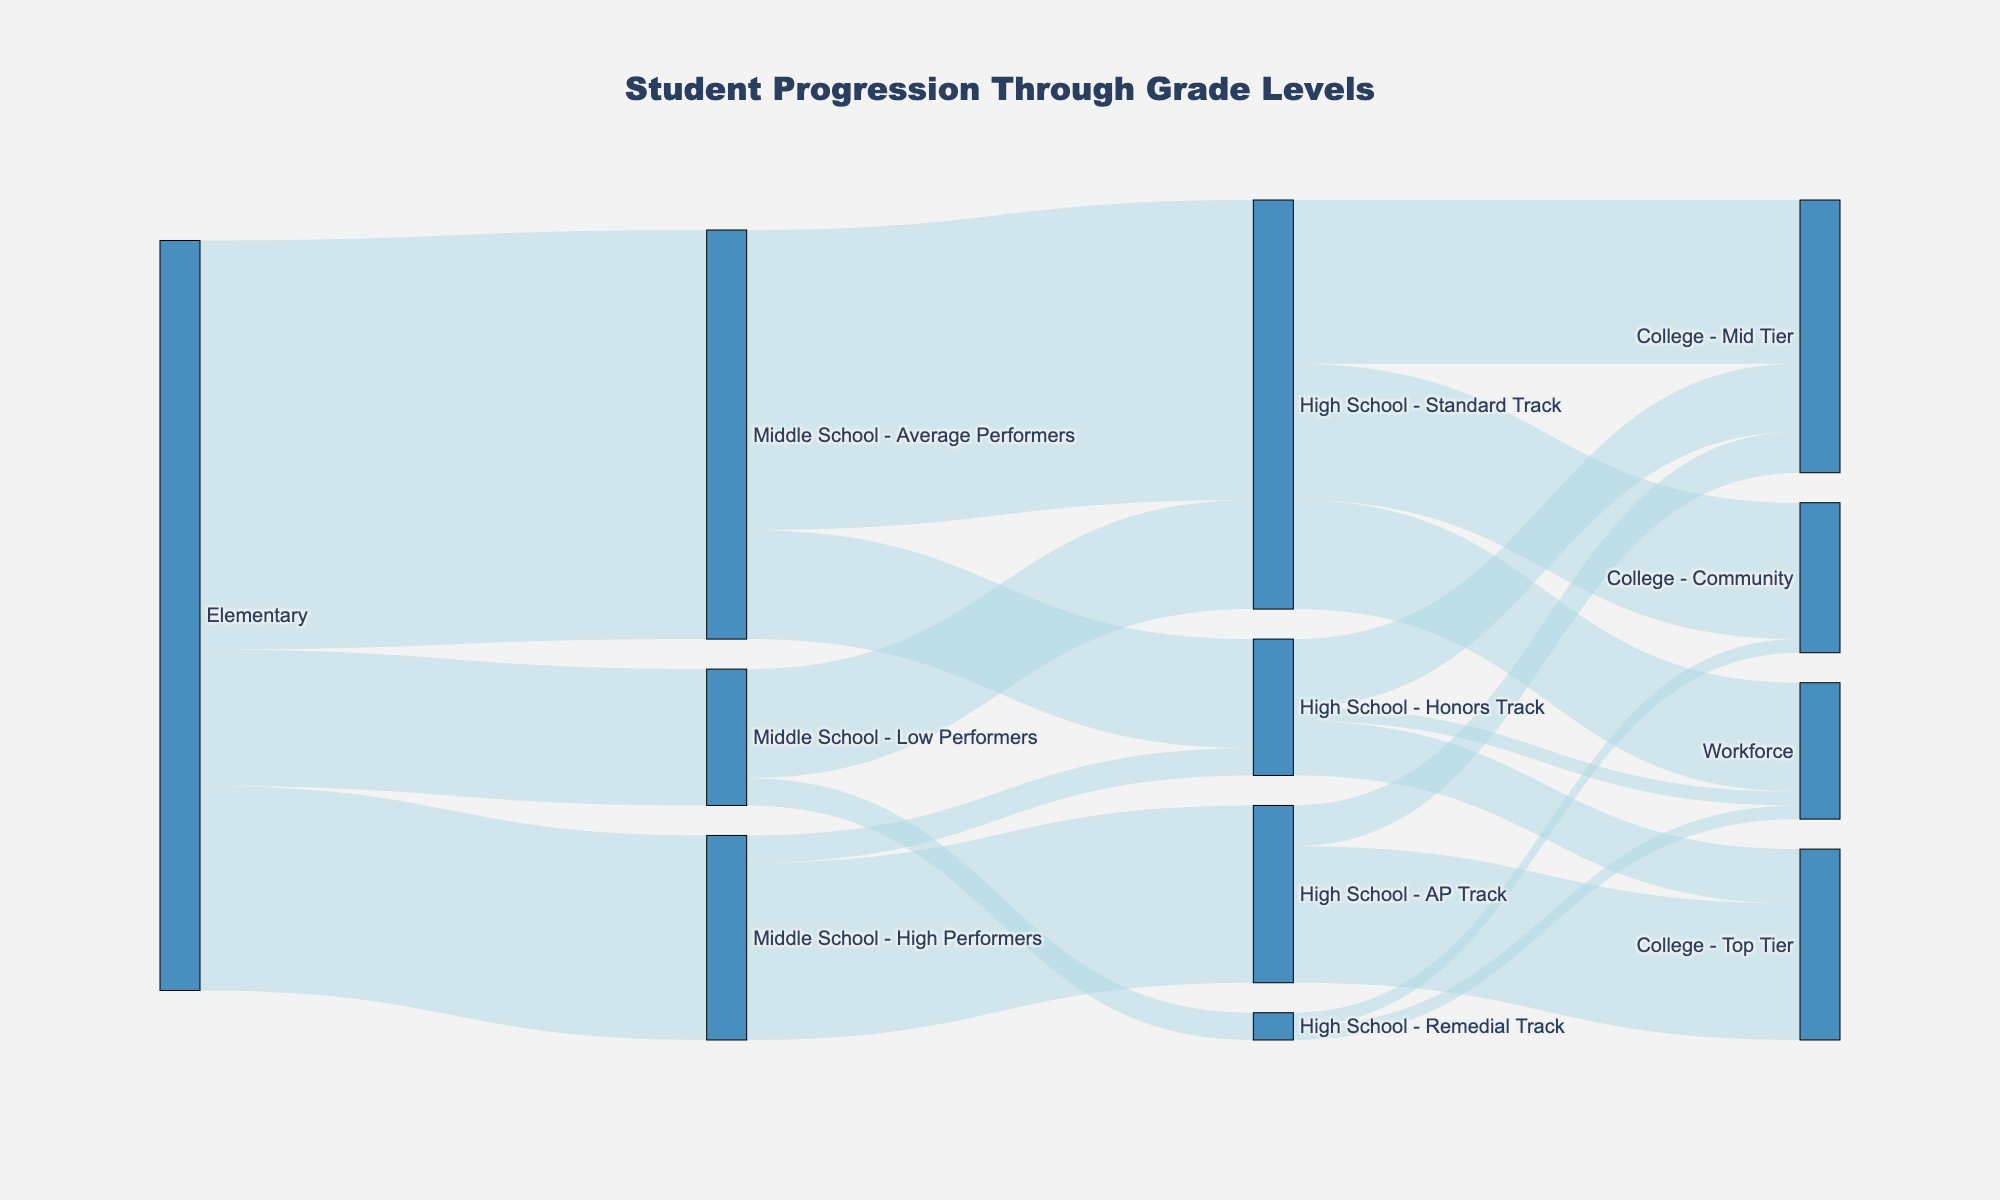What is the title of the figure? The title is usually located at the top of the diagram. In this case, it reads "Student Progression Through Grade Levels".
Answer: Student Progression Through Grade Levels How many students progressed from Middle School - High Performers to High School - AP Track? Find the link from Middle School - High Performers to High School - AP Track in the diagram, the value displayed is 130.
Answer: 130 Which group has the highest number of students entering High School - Standard Track? Examine the links flowing into High School - Standard Track. The flows are from Middle School - Average Performers (220) and Middle School - Low Performers (80). 220 is the higher value.
Answer: Middle School - Average Performers How many students transitioned from Elementary to Middle School? Sum the values for students transitioning from Elementary to all Middle School groups: Middle School - High Performers (150), Middle School - Average Performers (300), Middle School - Low Performers (100). So, 150 + 300 + 100 = 550.
Answer: 550 What is the total number of students who entered the workforce after High School? Sum the values for students entering the workforce from all High School tracks: High School - Honors Track (10), High School - Standard Track (80), High School - Remedial Track (10). So, 10 + 80 + 10 = 100.
Answer: 100 Which transition has the least number of students? Identify the link with the smallest value; here, it is the transition from Middle School - Low Performers to High School - Remedial Track, which has a value of 20.
Answer: Middle School - Low Performers to High School - Remedial Track How many students from High School - Standard Track went to any college? Sum the values leading to different colleges from High School - Standard Track: College - Mid Tier (120) and College - Community (100). Thus, 120 + 100 = 220.
Answer: 220 Did more students from Elementary transition to Middle School - Average Performers or High School - Standard Track? Compare the numbers transitioning from Elementary to Middle School - Average Performers (300) and the total from all sources to High School - Standard Track (220 + 80 = 300). Since 300 = 300, the numbers are equal.
Answer: Equal How many students in total moved from Middle School to High School? Sum all transitions from Middle School to High School tracks: to High School - AP Track (130), Honors Track (100), Standard Track (300), and Remedial Track (20). So, 130 + 100 + 300 + 20 = 550.
Answer: 550 